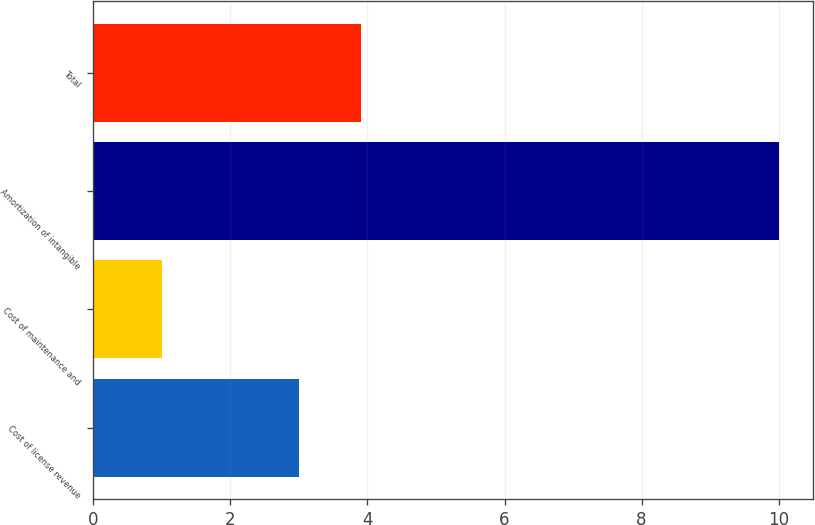Convert chart. <chart><loc_0><loc_0><loc_500><loc_500><bar_chart><fcel>Cost of license revenue<fcel>Cost of maintenance and<fcel>Amortization of intangible<fcel>Total<nl><fcel>3<fcel>1<fcel>10<fcel>3.9<nl></chart> 